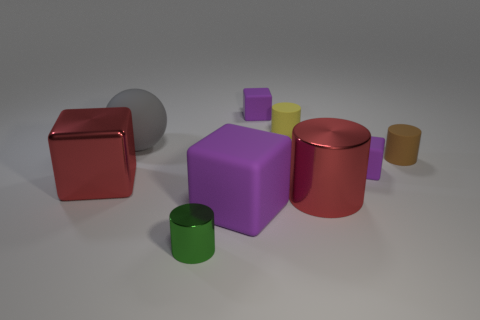What number of things are either large matte cubes that are on the left side of the small brown matte thing or small brown cylinders?
Make the answer very short. 2. What material is the purple block in front of the big cube behind the large purple block?
Make the answer very short. Rubber. Are there any large shiny things of the same shape as the yellow matte thing?
Provide a short and direct response. Yes. Does the red metal block have the same size as the red thing on the right side of the rubber sphere?
Your response must be concise. Yes. What number of objects are tiny things right of the tiny green cylinder or small purple cubes that are in front of the big gray thing?
Keep it short and to the point. 4. Is the number of purple things that are left of the tiny brown matte thing greater than the number of yellow matte objects?
Your response must be concise. Yes. What number of brown objects have the same size as the yellow matte cylinder?
Your response must be concise. 1. Does the metallic cylinder that is in front of the large purple thing have the same size as the purple rubber thing that is on the right side of the red cylinder?
Your answer should be compact. Yes. There is a shiny cylinder left of the large matte block; how big is it?
Your response must be concise. Small. There is a purple object that is right of the matte cube that is behind the large sphere; how big is it?
Keep it short and to the point. Small. 